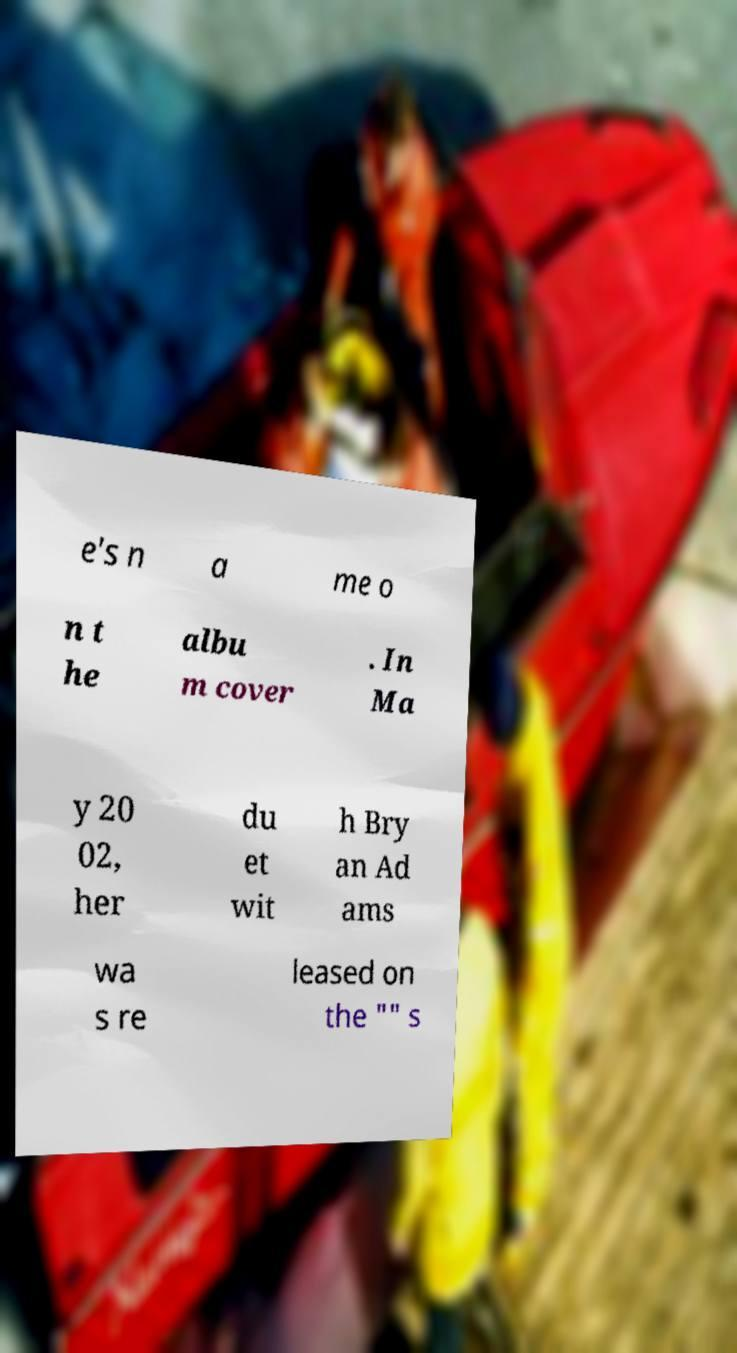Can you read and provide the text displayed in the image?This photo seems to have some interesting text. Can you extract and type it out for me? e's n a me o n t he albu m cover . In Ma y 20 02, her du et wit h Bry an Ad ams wa s re leased on the "" s 